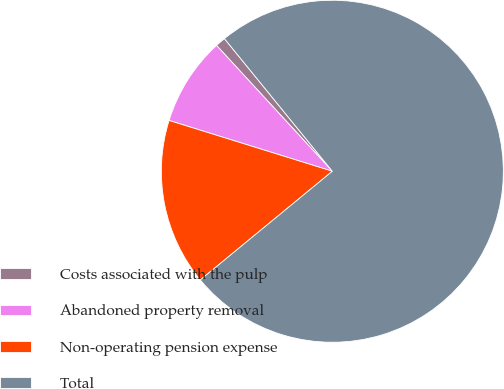Convert chart to OTSL. <chart><loc_0><loc_0><loc_500><loc_500><pie_chart><fcel>Costs associated with the pulp<fcel>Abandoned property removal<fcel>Non-operating pension expense<fcel>Total<nl><fcel>0.97%<fcel>8.36%<fcel>15.76%<fcel>74.91%<nl></chart> 